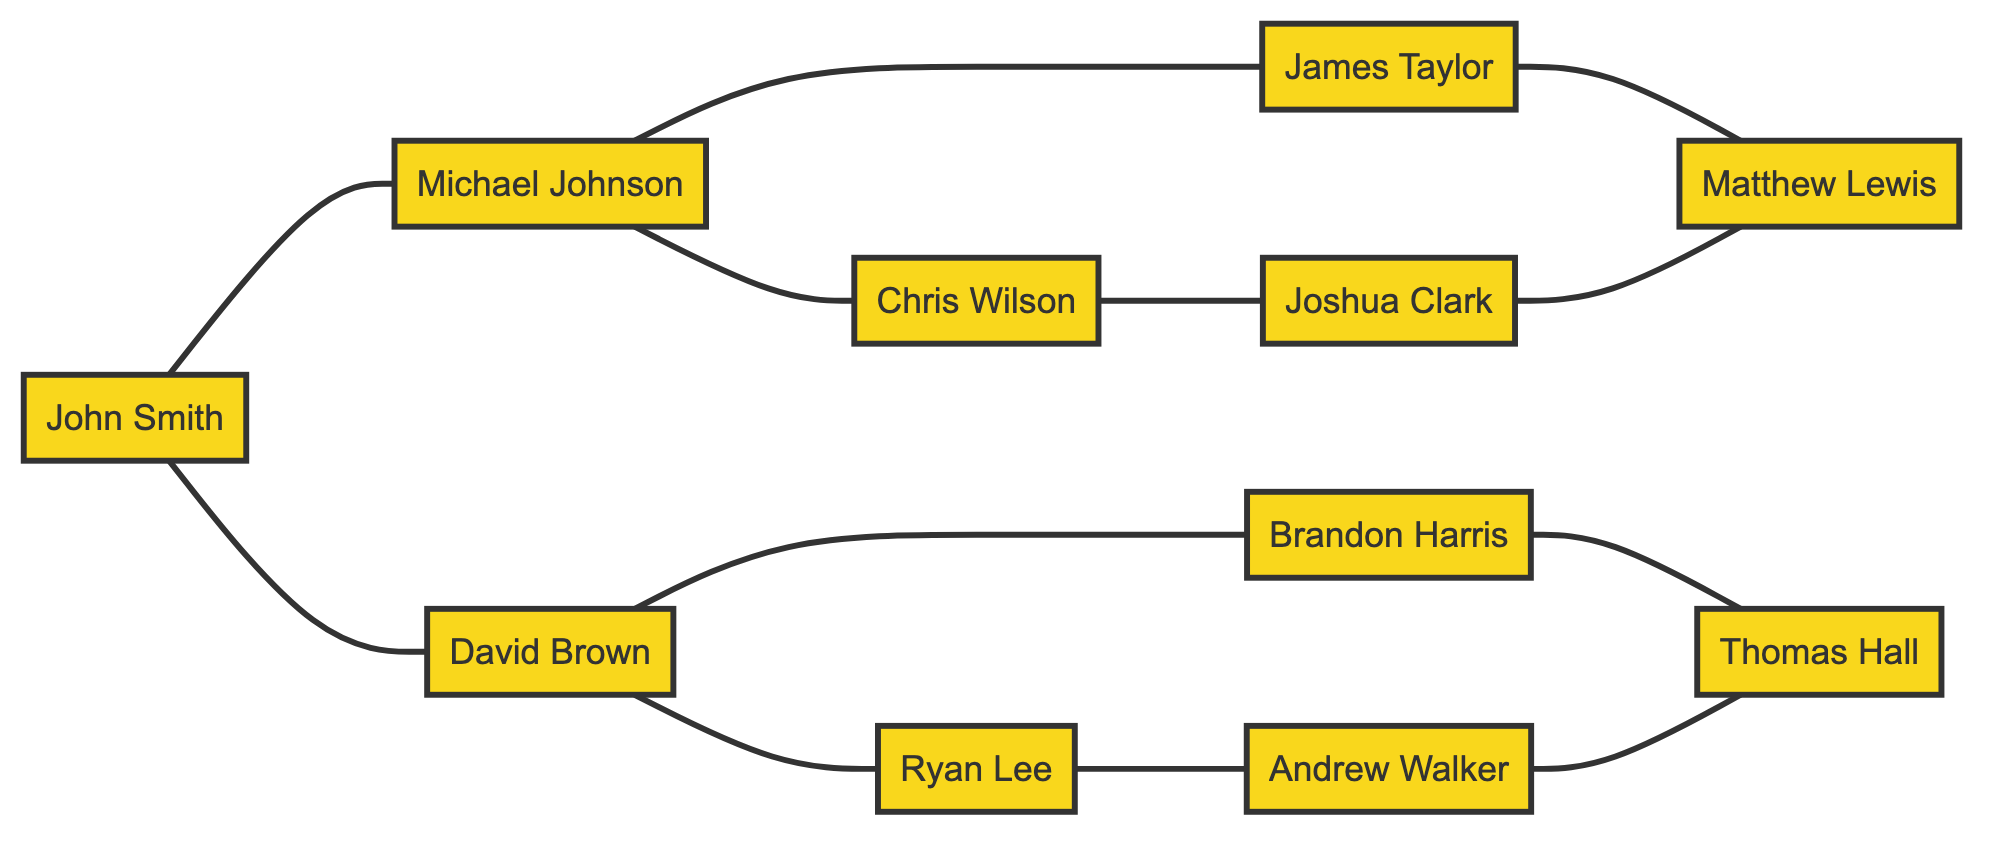What is the total number of players in the communication network? There are 11 nodes listed in the diagram, each representing a player.
Answer: 11 Which player is directly connected to John Smith? The diagram shows direct connections from John Smith (Player1) to Michael Johnson (Player2) and David Brown (Player3).
Answer: Michael Johnson, David Brown How many edges are connecting Michael Johnson? Michael Johnson (Player2) is connected to three other players: John Smith (Player1), Chris Wilson (Player4), and James Taylor (Player5). Thus, there are 3 edges connected to him.
Answer: 3 Who is the player connected to both Joshua Clark and Matthew Lewis? Looking at the diagram, Joshua Clark (Player8) is directly connected to Chris Wilson (Player4) and Matthew Lewis (Player9), which makes Matthew Lewis the player connected to both.
Answer: Matthew Lewis Which pair of players are not connected at all? By observing the diagram, Ryan Lee (Player6) and Chris Wilson (Player4) do not have a direct line connecting them, indicating they are not connected at all.
Answer: Ryan Lee, Chris Wilson What is the total number of edges in the network? To determine the total number of edges, we can count from the edges data: there are 11 edges listed, indicating connections between the players.
Answer: 11 Which player has the highest degree of connections? By examining the connections, Michael Johnson (Player2) connects to three players, which appears to be the maximum number of direct connections to other players in the network.
Answer: Michael Johnson How many players are directly connected to more than one player? Players such as John Smith, Michael Johnson, David Brown, Chris Wilson, James Taylor, Ryan Lee, and Andrew Walker have more than one connection, making a total of 7 players with multiple direct connections.
Answer: 7 Which player is connected to both Andrew Walker and Thomas Hall? The diagram shows that Andrew Walker (Player10) is connected to Thomas Hall (Player11) directly, indicating that they are indeed directly linked, linking them collectively.
Answer: Andrew Walker, Thomas Hall 